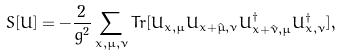<formula> <loc_0><loc_0><loc_500><loc_500>S [ U ] = - \frac { 2 } { g ^ { 2 } } \sum _ { x , \mu , \nu } T r [ U _ { x , \mu } U _ { x + \hat { \mu } , \nu } U _ { x + \hat { \nu } , \mu } ^ { \dagger } U _ { x , \nu } ^ { \dagger } ] ,</formula> 